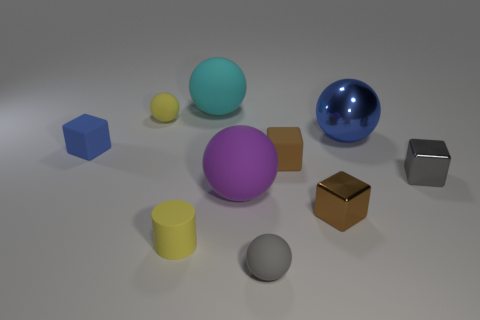Subtract all yellow balls. How many balls are left? 4 Subtract all cyan spheres. How many spheres are left? 4 Subtract all yellow blocks. Subtract all yellow balls. How many blocks are left? 4 Add 8 cyan rubber things. How many cyan rubber things are left? 9 Add 7 large red cubes. How many large red cubes exist? 7 Subtract 0 green cylinders. How many objects are left? 10 Subtract all cylinders. How many objects are left? 9 Subtract 1 cylinders. How many cylinders are left? 0 Subtract all yellow spheres. How many blue cubes are left? 1 Subtract all small cyan rubber cylinders. Subtract all large blue metal objects. How many objects are left? 9 